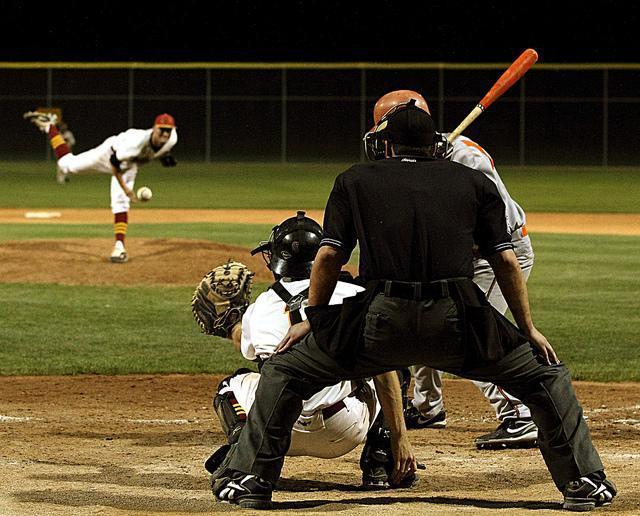How many people are there?
Give a very brief answer. 4. How many birds are going to fly there in the image?
Give a very brief answer. 0. 